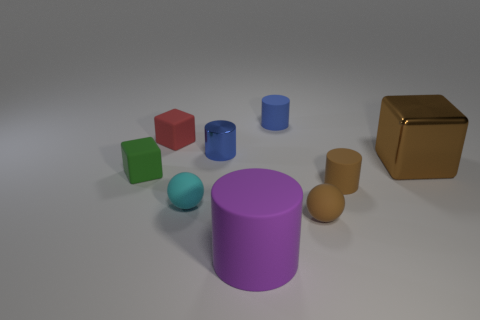What size is the rubber cube that is in front of the large thing that is behind the large object left of the brown metallic block?
Offer a very short reply. Small. What is the shape of the big thing that is right of the small blue object behind the tiny blue metallic cylinder?
Keep it short and to the point. Cube. Does the tiny rubber cylinder on the left side of the brown rubber cylinder have the same color as the big rubber thing?
Provide a short and direct response. No. What color is the small rubber thing that is right of the small metal cylinder and behind the brown cylinder?
Provide a succinct answer. Blue. Is there a tiny green block made of the same material as the small red thing?
Make the answer very short. Yes. The brown cylinder has what size?
Your response must be concise. Small. There is a brown block in front of the block that is behind the small blue metallic cylinder; how big is it?
Keep it short and to the point. Large. There is a brown object that is the same shape as the purple thing; what is its material?
Offer a terse response. Rubber. How many large gray rubber blocks are there?
Ensure brevity in your answer.  0. There is a cylinder to the right of the object behind the small rubber block behind the small green matte cube; what color is it?
Make the answer very short. Brown. 